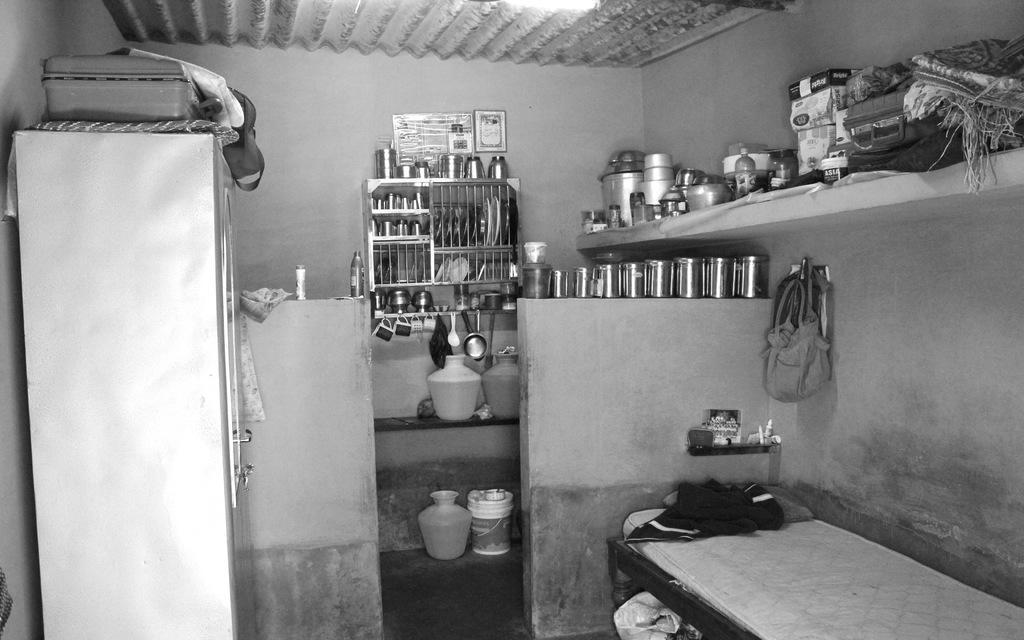Can you describe this image briefly? This picture is in black and white. This picture is clicked inside the room. In the right bottom of the picture, we see a bed. Beside that, we see a wall and a handbag is hanged to the wall. Beside that, we see steel boxes are placed on the wall. We see many vessels and suitcase are placed on the shelf. Beside that, we see a steel stand in which many plates, vessels and glasses are placed. In the middle of the picture, we see a countertop on which plastic water vessels are placed. Below that, we see a bucket. On the left side, we see a cupboard and a suitcase. 